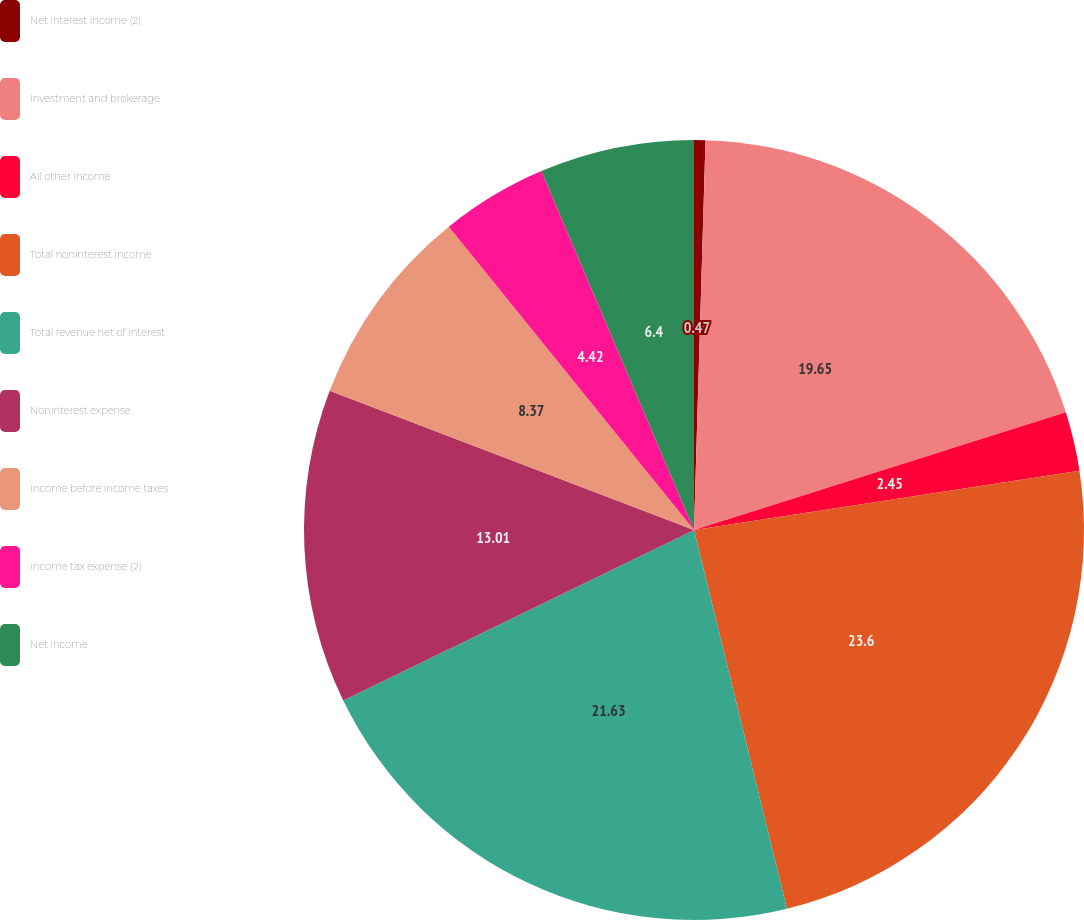<chart> <loc_0><loc_0><loc_500><loc_500><pie_chart><fcel>Net interest income (2)<fcel>Investment and brokerage<fcel>All other income<fcel>Total noninterest income<fcel>Total revenue net of interest<fcel>Noninterest expense<fcel>Income before income taxes<fcel>Income tax expense (2)<fcel>Net income<nl><fcel>0.47%<fcel>19.65%<fcel>2.45%<fcel>23.6%<fcel>21.63%<fcel>13.01%<fcel>8.37%<fcel>4.42%<fcel>6.4%<nl></chart> 